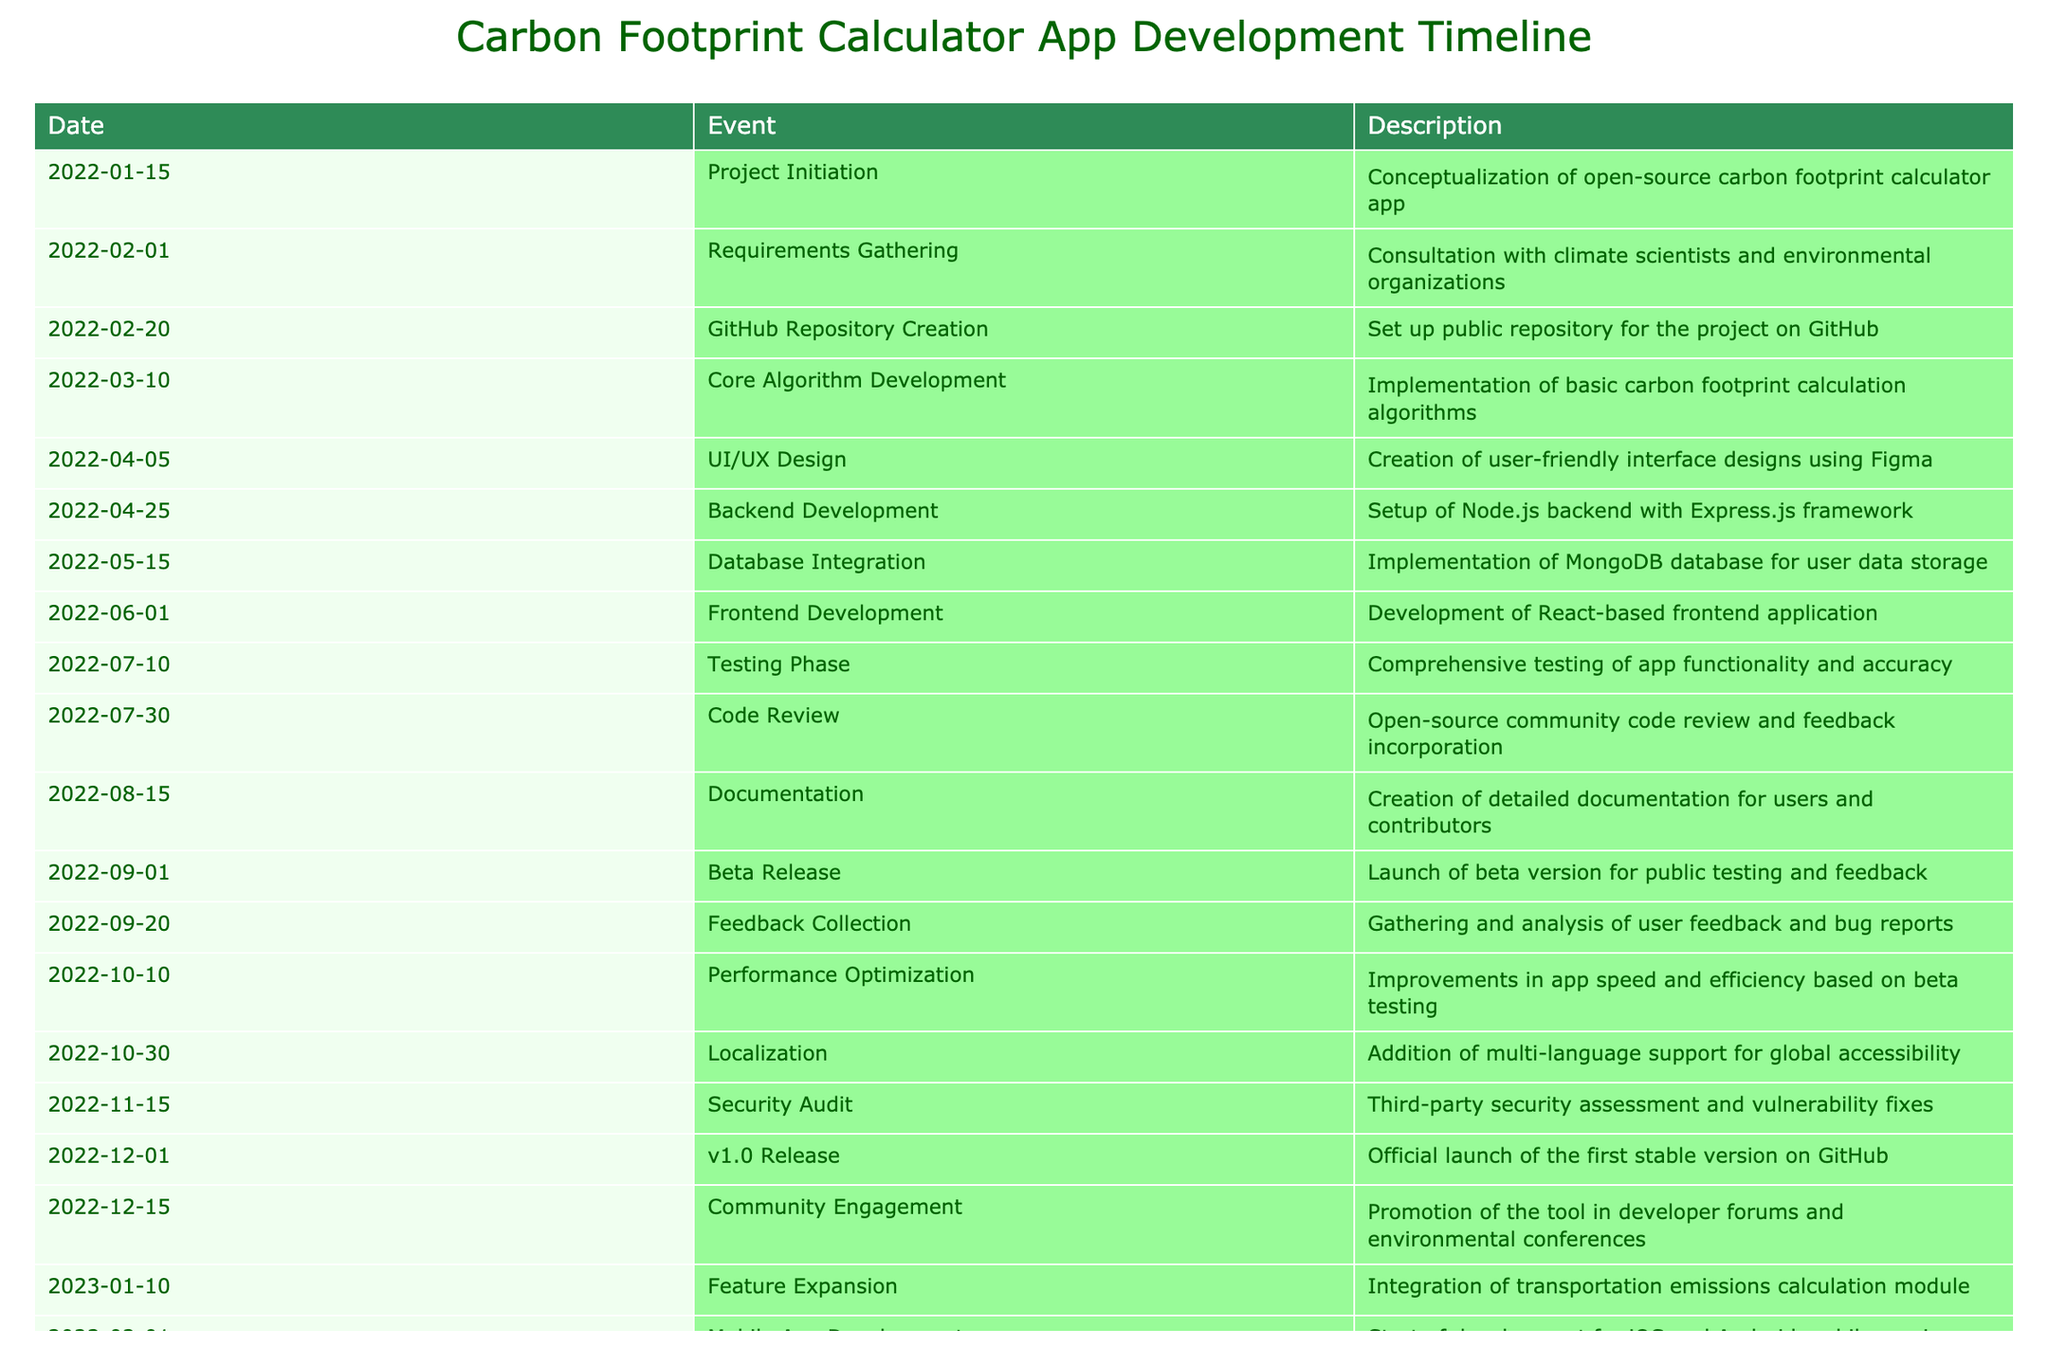What event occurred on January 15, 2022? The table shows that the event on January 15, 2022, is the initiation of the project, which involved the conceptualization of the open-source carbon footprint calculator app.
Answer: Project Initiation What was the purpose of the requirements gathering phase? The requirements gathering phase involved consultation with climate scientists and environmental organizations to identify necessary features and data for the app. The description provided in the table specifies this purpose.
Answer: Consultation with climate scientists and environmental organizations How many months were there between the beta release and the v1.0 release? The beta release occurred on September 1, 2022, and the v1.0 release was on December 1, 2022. Counting the number of months from September to December gives us three months.
Answer: 3 Did the project include a phase for code review? Yes, the table indicates that there was a code review phase on July 30, 2022, where the open-source community provided feedback and suggestions for improvement.
Answer: Yes What two significant developments occurred in early 2023? The table shows two significant developments in early 2023: the integration of a transportation emissions calculation module on January 10, 2023, and the start of development for iOS and Android mobile versions on February 1, 2023.
Answer: Feature Expansion and Mobile App Development What were the major steps taken before the official release of version 1.0? Prior to the official v1.0 release on December 1, 2022, several steps were taken: feedback collection on September 20, performance optimization on October 10, localization on October 30, and a security audit on November 15. This series of events shows the thorough preparation before the official launch.
Answer: Feedback Collection, Performance Optimization, Localization, Security Audit What features were implemented before the first stable version was launched? Before the v1.0 release, core algorithm development, database integration, UI/UX design, frontend development, backend development, testing phase, code review, documentation, and security audit were all implemented. Each of these steps contributed critical functionalities and reliability to the application.
Answer: Core Algorithm, Database, UI/UX, Frontend, Backend, Testing, Code Review, Documentation, Security Audit Was community engagement part of the project after the first stable release? Yes, the table shows that community engagement took place on December 15, 2022, after the v1.0 release, which involved promoting the tool in developer forums and environmental conferences.
Answer: Yes 